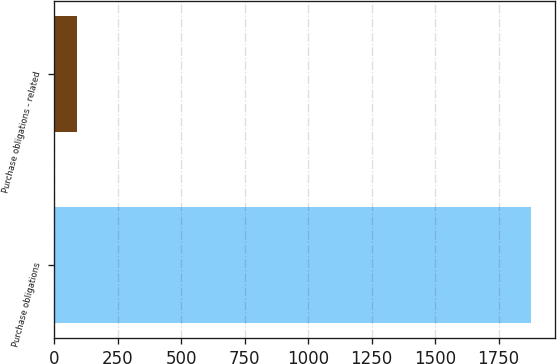<chart> <loc_0><loc_0><loc_500><loc_500><bar_chart><fcel>Purchase obligations<fcel>Purchase obligations - related<nl><fcel>1879<fcel>89<nl></chart> 